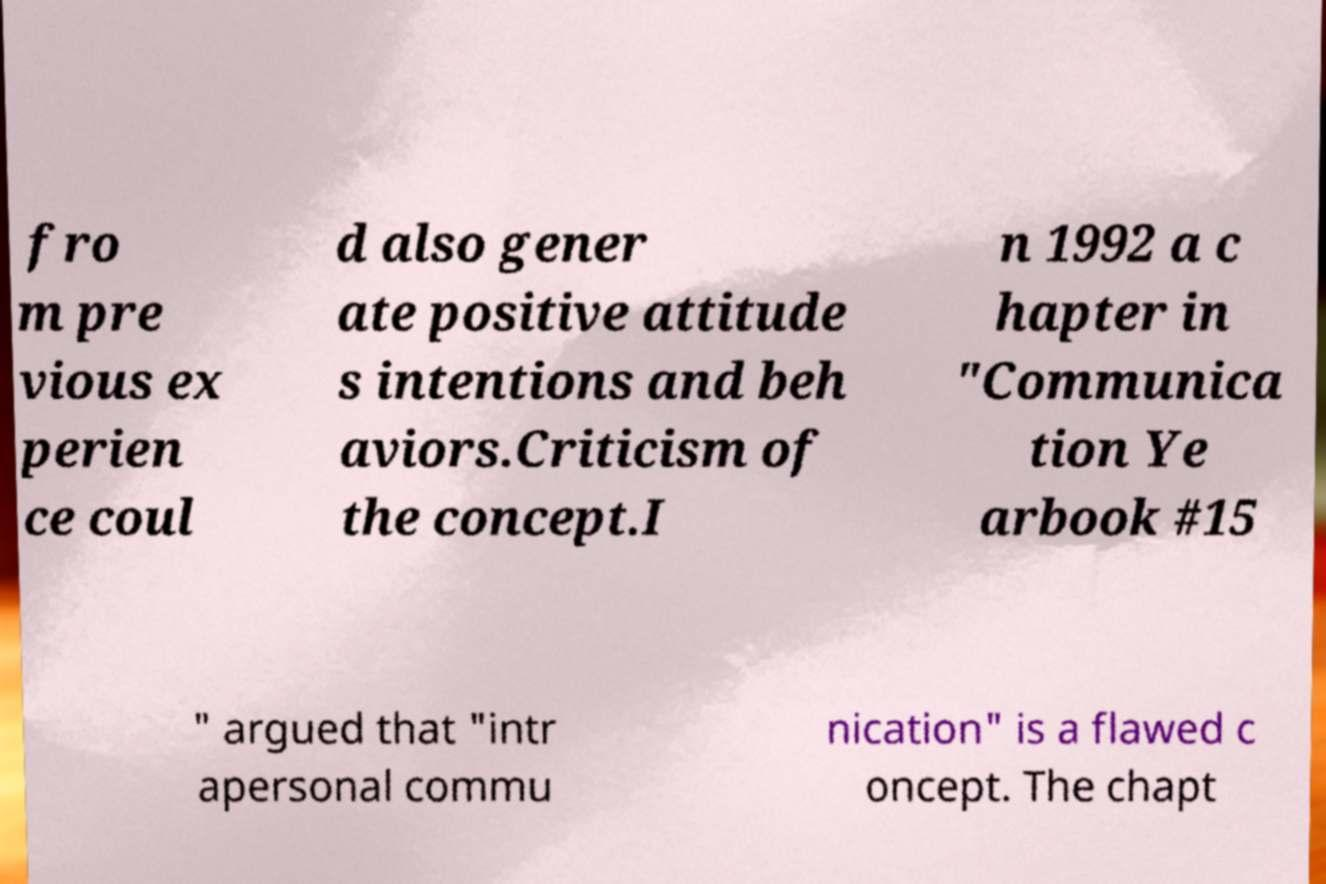Please identify and transcribe the text found in this image. fro m pre vious ex perien ce coul d also gener ate positive attitude s intentions and beh aviors.Criticism of the concept.I n 1992 a c hapter in "Communica tion Ye arbook #15 " argued that "intr apersonal commu nication" is a flawed c oncept. The chapt 